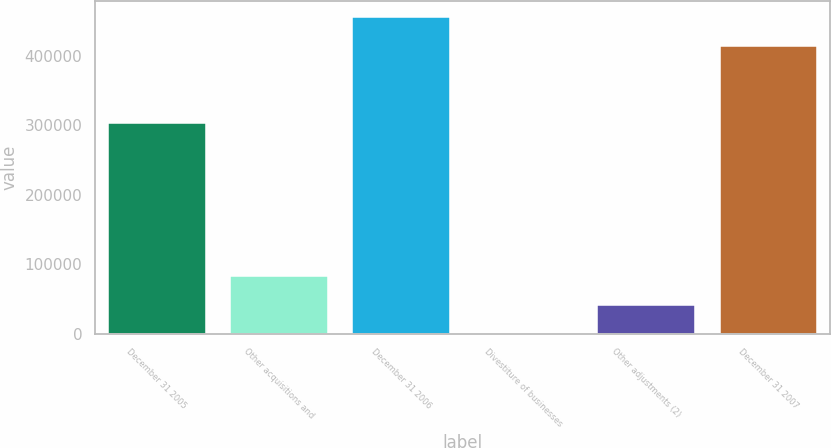<chart> <loc_0><loc_0><loc_500><loc_500><bar_chart><fcel>December 31 2005<fcel>Other acquisitions and<fcel>December 31 2006<fcel>Divestiture of businesses<fcel>Other adjustments (2)<fcel>December 31 2007<nl><fcel>304060<fcel>83305.6<fcel>456212<fcel>184<fcel>41744.8<fcel>414651<nl></chart> 